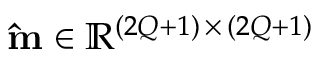<formula> <loc_0><loc_0><loc_500><loc_500>\hat { m } \in \mathbb { R } ^ { ( 2 Q + 1 ) \, \times \, ( 2 Q + 1 ) }</formula> 